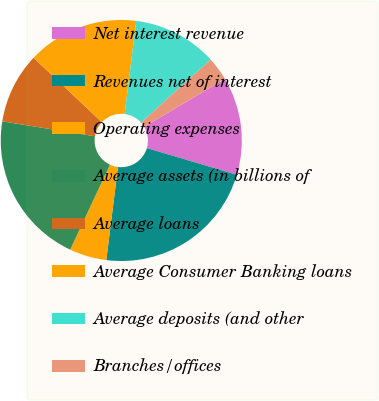Convert chart to OTSL. <chart><loc_0><loc_0><loc_500><loc_500><pie_chart><fcel>Net interest revenue<fcel>Revenues net of interest<fcel>Operating expenses<fcel>Average assets (in billions of<fcel>Average loans<fcel>Average Consumer Banking loans<fcel>Average deposits (and other<fcel>Branches/offices<nl><fcel>13.13%<fcel>22.39%<fcel>4.98%<fcel>20.57%<fcel>9.49%<fcel>14.95%<fcel>11.31%<fcel>3.16%<nl></chart> 